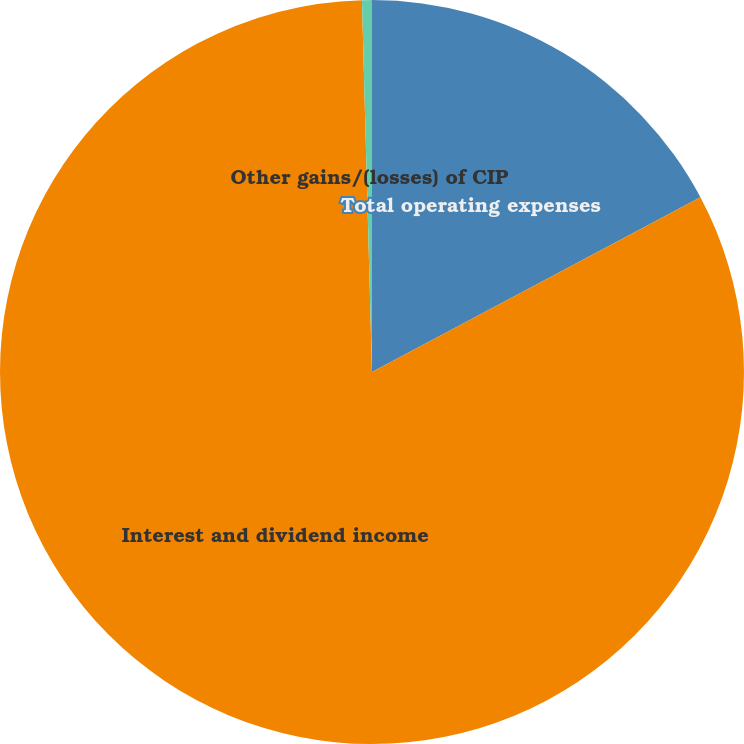Convert chart to OTSL. <chart><loc_0><loc_0><loc_500><loc_500><pie_chart><fcel>Total operating expenses<fcel>Interest and dividend income<fcel>Other gains/(losses) of CIP<nl><fcel>17.22%<fcel>82.35%<fcel>0.43%<nl></chart> 